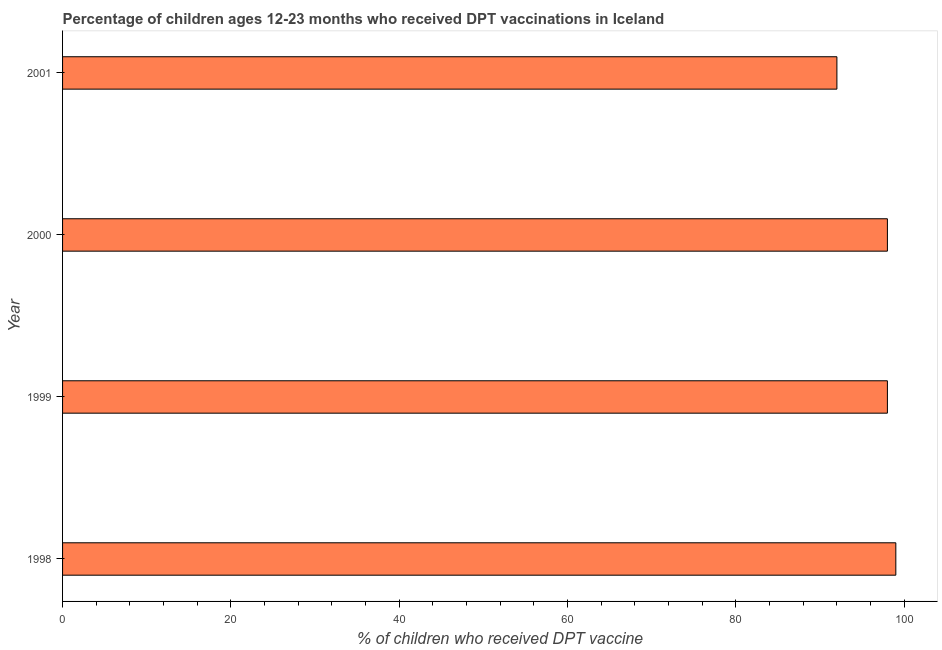Does the graph contain grids?
Your answer should be very brief. No. What is the title of the graph?
Provide a short and direct response. Percentage of children ages 12-23 months who received DPT vaccinations in Iceland. What is the label or title of the X-axis?
Ensure brevity in your answer.  % of children who received DPT vaccine. Across all years, what is the maximum percentage of children who received dpt vaccine?
Offer a terse response. 99. Across all years, what is the minimum percentage of children who received dpt vaccine?
Provide a succinct answer. 92. In which year was the percentage of children who received dpt vaccine maximum?
Make the answer very short. 1998. In which year was the percentage of children who received dpt vaccine minimum?
Offer a terse response. 2001. What is the sum of the percentage of children who received dpt vaccine?
Your answer should be compact. 387. What is the average percentage of children who received dpt vaccine per year?
Give a very brief answer. 96. What is the median percentage of children who received dpt vaccine?
Offer a very short reply. 98. In how many years, is the percentage of children who received dpt vaccine greater than 28 %?
Offer a very short reply. 4. Do a majority of the years between 1999 and 2001 (inclusive) have percentage of children who received dpt vaccine greater than 32 %?
Make the answer very short. Yes. Is the percentage of children who received dpt vaccine in 1998 less than that in 1999?
Give a very brief answer. No. What is the difference between the highest and the second highest percentage of children who received dpt vaccine?
Provide a short and direct response. 1. Is the sum of the percentage of children who received dpt vaccine in 2000 and 2001 greater than the maximum percentage of children who received dpt vaccine across all years?
Offer a very short reply. Yes. What is the difference between the highest and the lowest percentage of children who received dpt vaccine?
Provide a short and direct response. 7. Are all the bars in the graph horizontal?
Provide a succinct answer. Yes. How many years are there in the graph?
Your answer should be compact. 4. What is the difference between two consecutive major ticks on the X-axis?
Provide a short and direct response. 20. What is the % of children who received DPT vaccine in 1998?
Your response must be concise. 99. What is the % of children who received DPT vaccine of 1999?
Offer a very short reply. 98. What is the % of children who received DPT vaccine in 2000?
Offer a terse response. 98. What is the % of children who received DPT vaccine in 2001?
Your answer should be very brief. 92. What is the difference between the % of children who received DPT vaccine in 1998 and 2001?
Your answer should be compact. 7. What is the difference between the % of children who received DPT vaccine in 1999 and 2001?
Provide a succinct answer. 6. What is the difference between the % of children who received DPT vaccine in 2000 and 2001?
Ensure brevity in your answer.  6. What is the ratio of the % of children who received DPT vaccine in 1998 to that in 2000?
Give a very brief answer. 1.01. What is the ratio of the % of children who received DPT vaccine in 1998 to that in 2001?
Offer a very short reply. 1.08. What is the ratio of the % of children who received DPT vaccine in 1999 to that in 2000?
Ensure brevity in your answer.  1. What is the ratio of the % of children who received DPT vaccine in 1999 to that in 2001?
Your answer should be very brief. 1.06. What is the ratio of the % of children who received DPT vaccine in 2000 to that in 2001?
Your response must be concise. 1.06. 